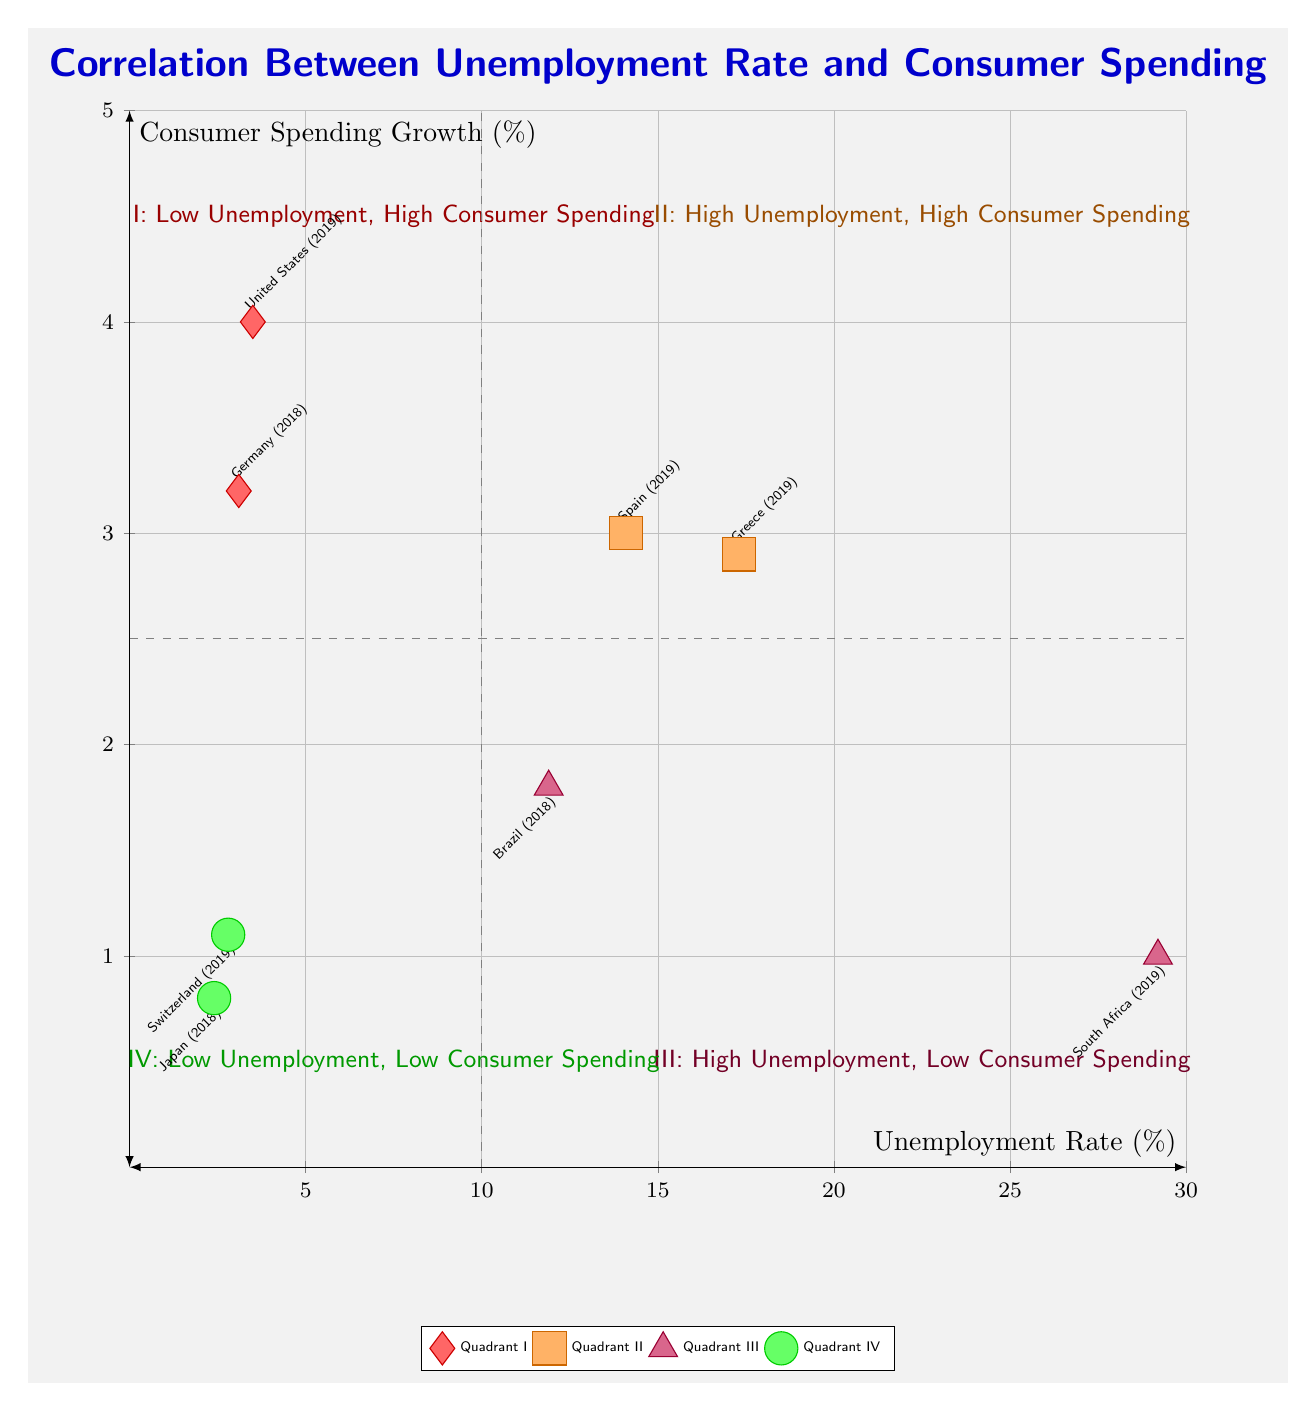What countries are in Quadrant I? Quadrant I contains the countries with low unemployment and high consumer spending. According to the data points in that quadrant, the countries listed are the United States and Germany.
Answer: United States, Germany What is the unemployment rate of South Africa? The data point for South Africa is located in Quadrant III, where high unemployment and low consumer spending are depicted. South Africa's unemployment rate is noted as 29.2%.
Answer: 29.2 Which quadrant has countries with both high unemployment and high consumer spending? Based on the quadrant descriptions, Quadrant II is defined as having high unemployment and high consumer spending. The data points confirm this with Greece and Spain.
Answer: Quadrant II What is the consumer spending growth for Japan? Japan is located in Quadrant IV which indicates low unemployment and low consumer spending. The consumer spending growth value associated with Japan is listed as 0.8%.
Answer: 0.8 How many countries are in Quadrant III? Quadrant III is populated with two data points representing country data. Therefore, the count of countries in that quadrant can be directly identified from the data provided. The countries are South Africa and Brazil, leading to a total of two.
Answer: 2 Which country has the highest unemployment rate among those listed? By examining the unemployment rates across the provided countries in the chart, South Africa, with an unemployment rate of 29.2%, is the highest. This requires comparing all the figures from every country in the quadrants.
Answer: South Africa What is the relationship between unemployment rate and consumer spending in Quadrant IV? Quadrant IV contains countries that exhibit low unemployment coupled with low consumer spending. The countries Japan and Switzerland illustrate this correlation clearly in the diagram.
Answer: Low Unemployment, Low Consumer Spending Name a country from Quadrant II. Quadrant II features data points for countries experiencing high unemployment and high consumer spending. The specific countries listed in this quadrant include Greece and Spain, either can be correctly identified.
Answer: Greece (or Spain) 